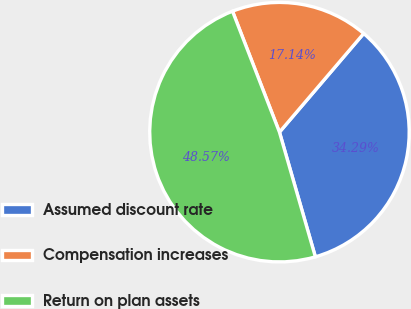Convert chart. <chart><loc_0><loc_0><loc_500><loc_500><pie_chart><fcel>Assumed discount rate<fcel>Compensation increases<fcel>Return on plan assets<nl><fcel>34.29%<fcel>17.14%<fcel>48.57%<nl></chart> 